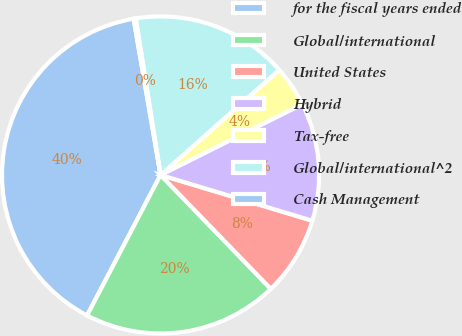Convert chart. <chart><loc_0><loc_0><loc_500><loc_500><pie_chart><fcel>for the fiscal years ended<fcel>Global/international<fcel>United States<fcel>Hybrid<fcel>Tax-free<fcel>Global/international^2<fcel>Cash Management<nl><fcel>39.61%<fcel>19.91%<fcel>8.1%<fcel>12.03%<fcel>4.16%<fcel>15.97%<fcel>0.22%<nl></chart> 